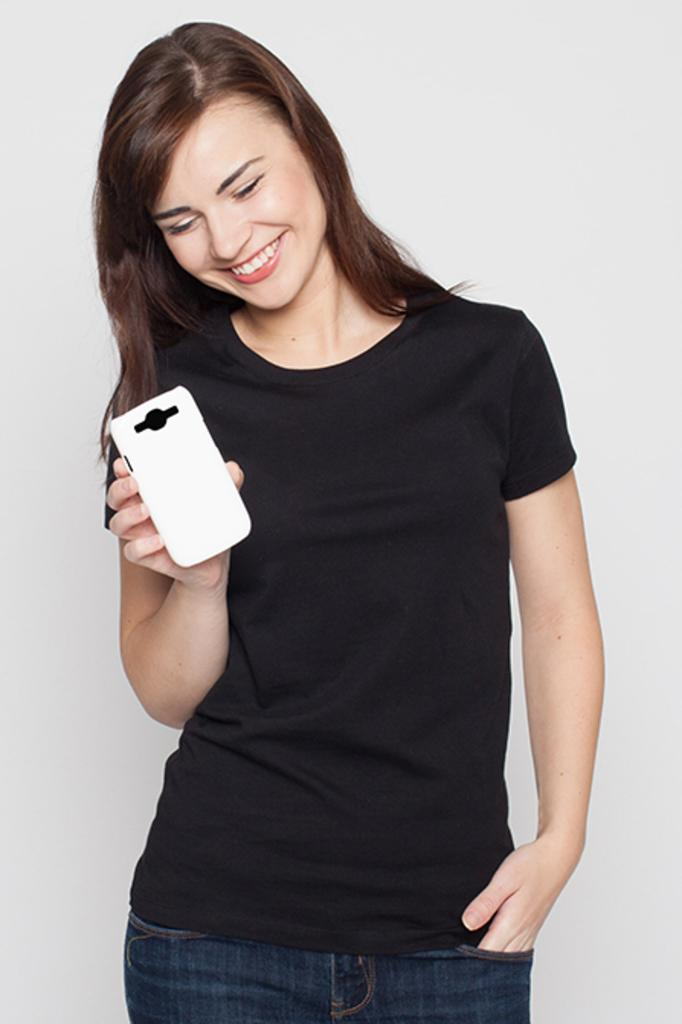Who is the main subject in the image? There is a girl in the image. Where is the girl located in the image? The girl is in the center of the image. What is the girl holding in her hand? The girl is holding a phone in her hand. What type of baseball equipment can be seen in the image? There is no baseball equipment present in the image; it features a girl holding a phone. What relation does the girl have to the person on the other end of the phone call? The image does not provide information about the girl's relationship to the person on the other end of the phone call. 